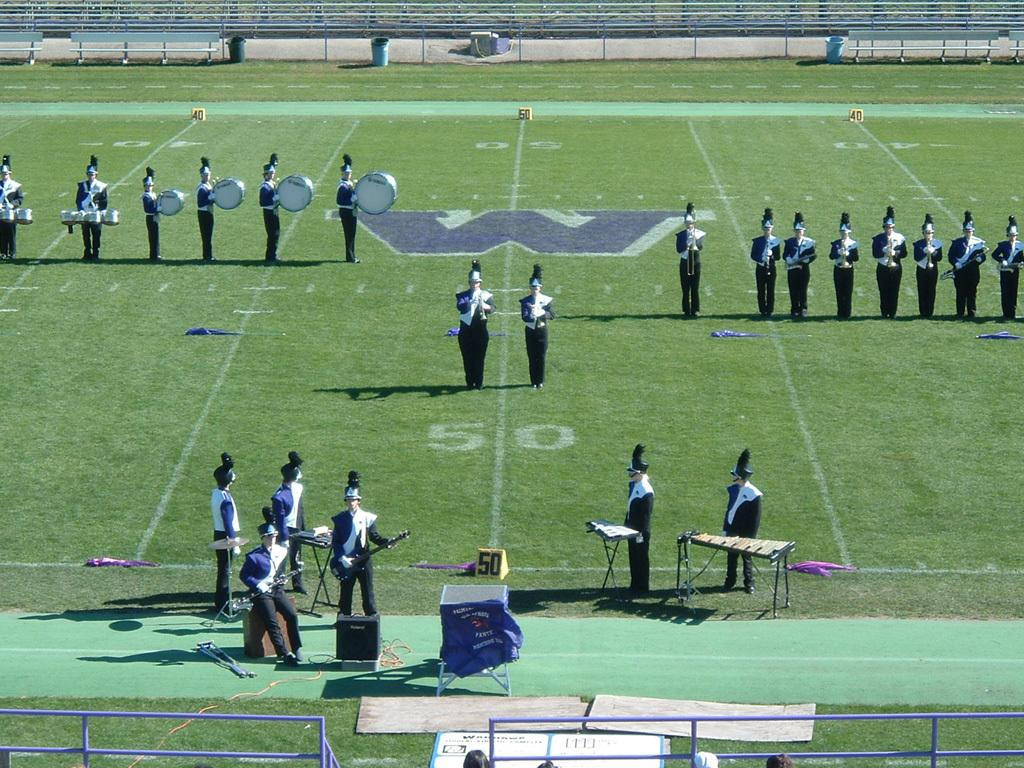<image>
Describe the image concisely. The band is on a football field with Yamaha bass drums 